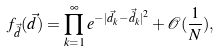Convert formula to latex. <formula><loc_0><loc_0><loc_500><loc_500>f _ { \vec { \tilde { d } } } ( \vec { d } ) = \prod _ { k = 1 } ^ { \infty } e ^ { - | \vec { d } _ { k } - \vec { \tilde { d } } _ { k } | ^ { 2 } } + \mathcal { O } ( \frac { 1 } { N } ) ,</formula> 